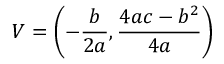<formula> <loc_0><loc_0><loc_500><loc_500>V = \left ( - { \frac { b } { 2 a } } , { \frac { 4 a c - b ^ { 2 } } { 4 a } } \right )</formula> 